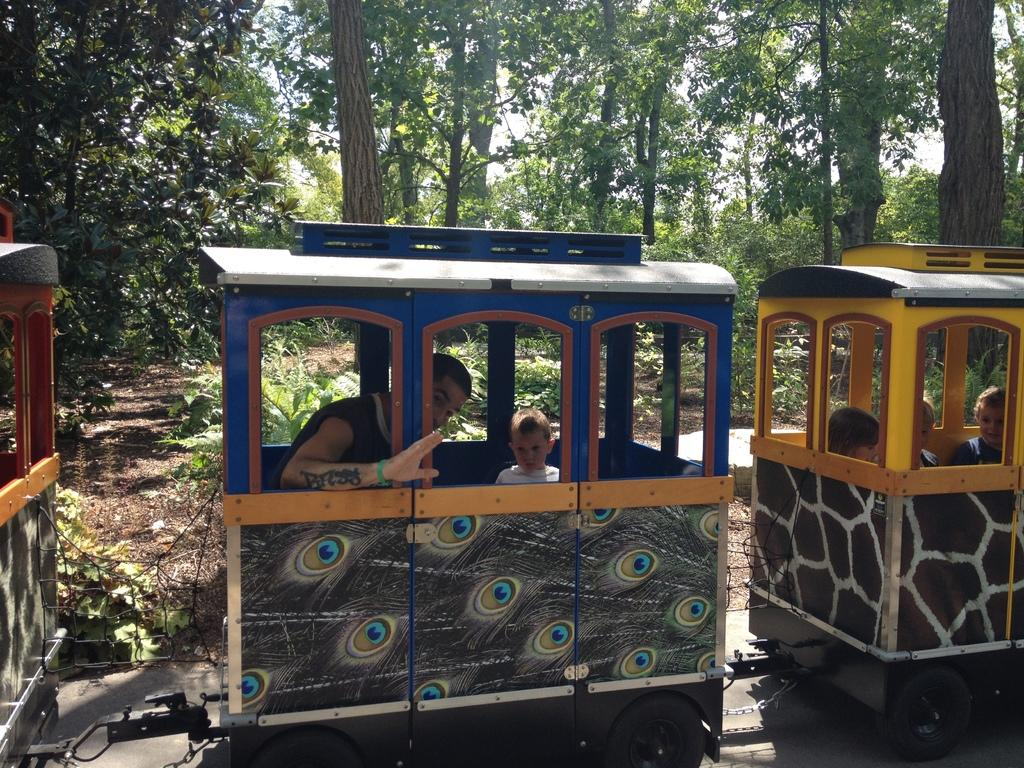What is the main subject of the image? The main subject of the image is a train. What is the train doing in the image? The train is moving on a track. Are there any passengers in the train? Yes, there are people sitting in the train's coaches. What can be seen in the background of the image? There are trees and the sky visible in the background of the image. What type of judge can be seen in the image? There is no judge present in the image; it features a train moving on a track with passengers inside. Can you tell me how many firemen are visible in the image? There are no firemen present in the image; it only shows a train and its passengers. 